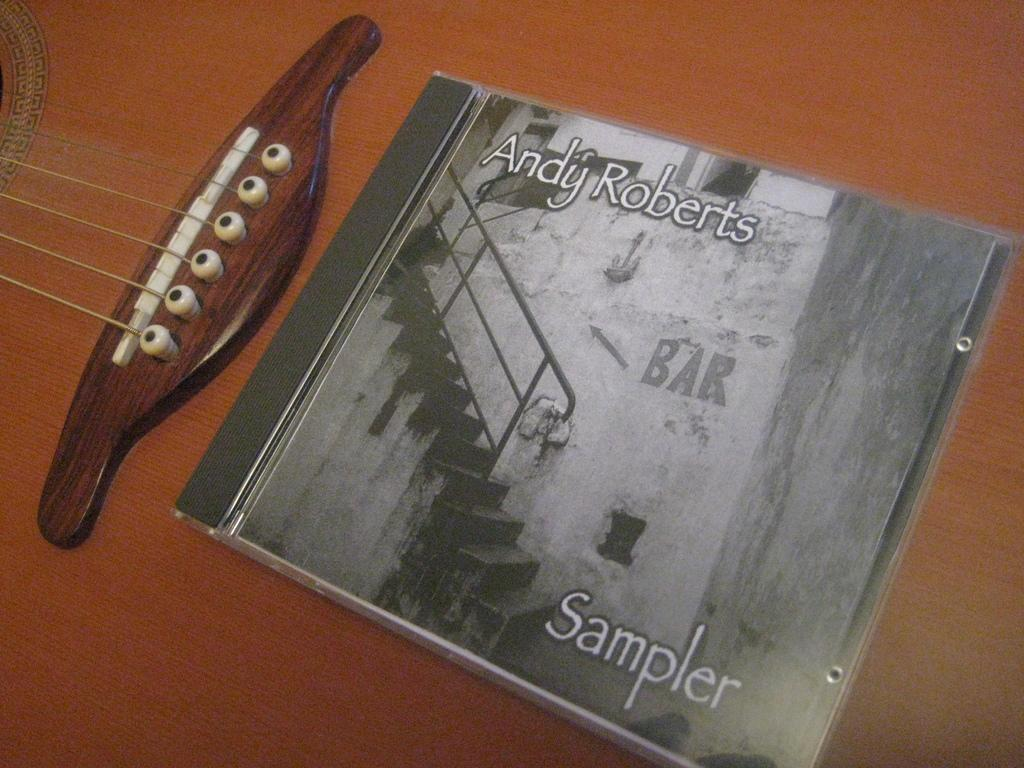What object in the image is used for creating music? There is a musical instrument in the image. What type of object is present for storing music? There is a CD case in the image. What can be found on the CD case besides the case itself? The CD case has text on it. What image is depicted on the CD case? The CD case has an image of a step with railing. Are there any pets visible in the image? There are no pets present in the image. Is the image taken in a snowy environment? The image does not depict a snowy environment; there is no mention of snow in the provided facts. 